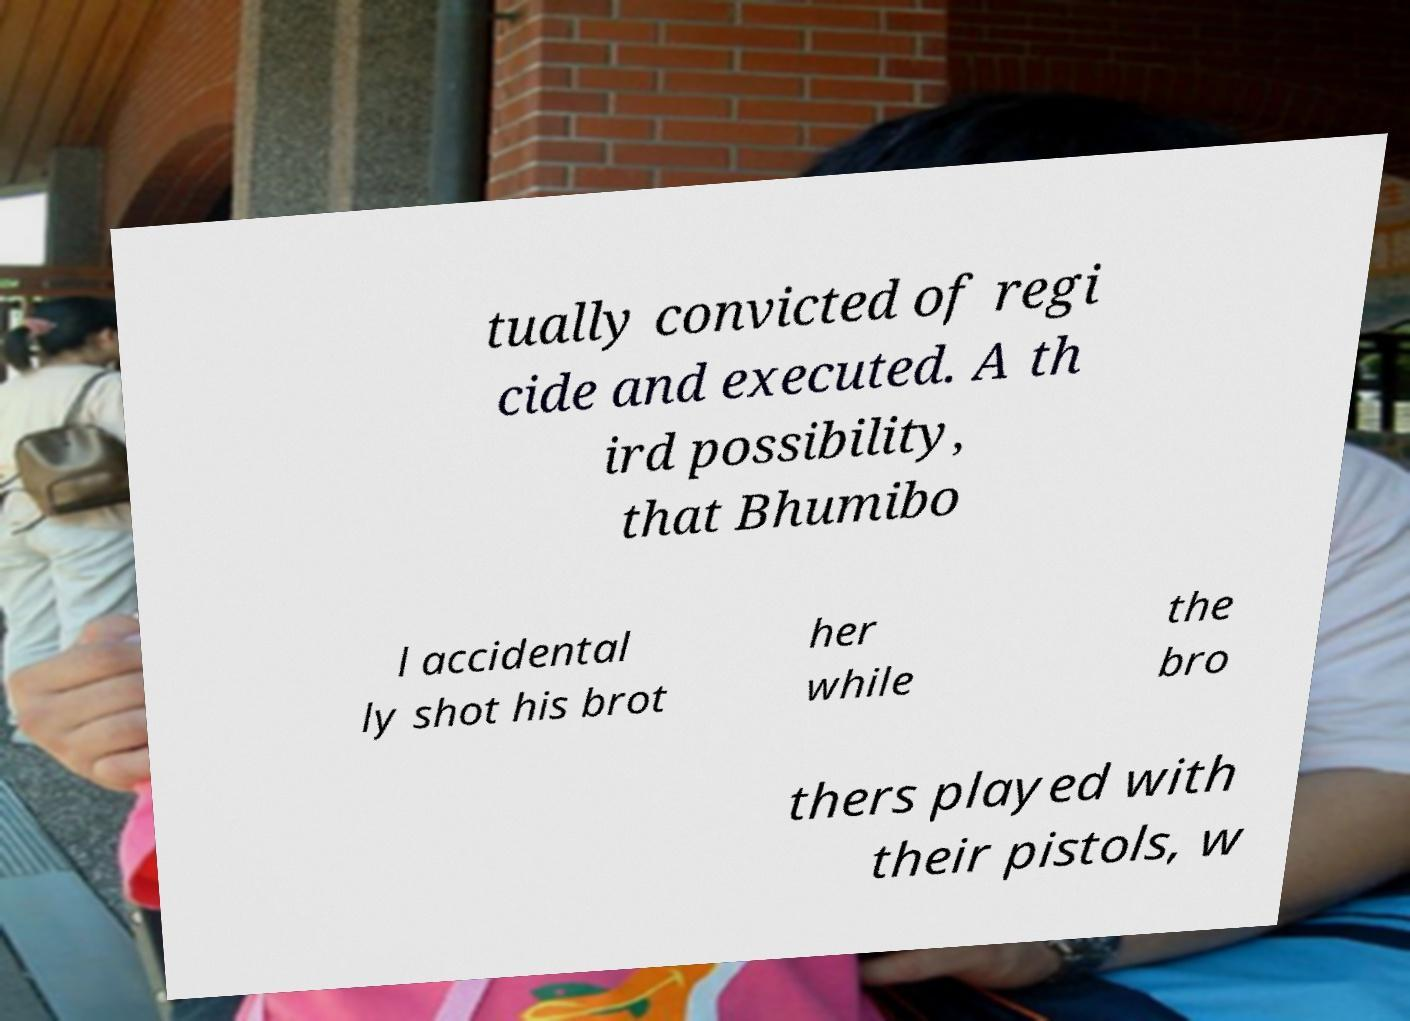I need the written content from this picture converted into text. Can you do that? tually convicted of regi cide and executed. A th ird possibility, that Bhumibo l accidental ly shot his brot her while the bro thers played with their pistols, w 